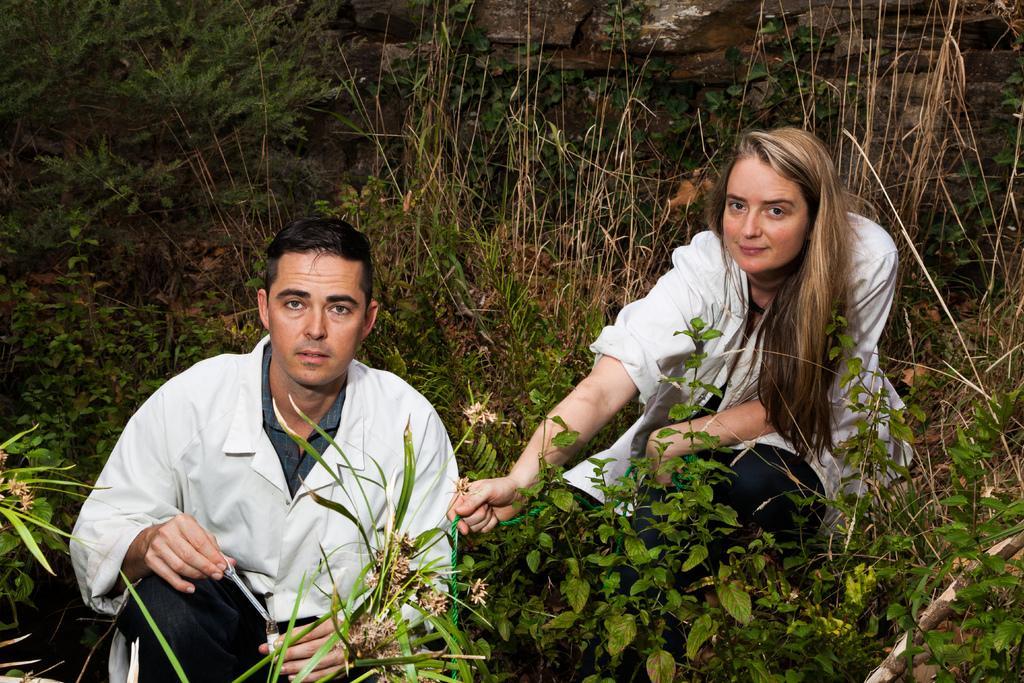Please provide a concise description of this image. In this picture I can observe a man and woman in the middle of the picture. In the background I can observe some plants on the ground. 